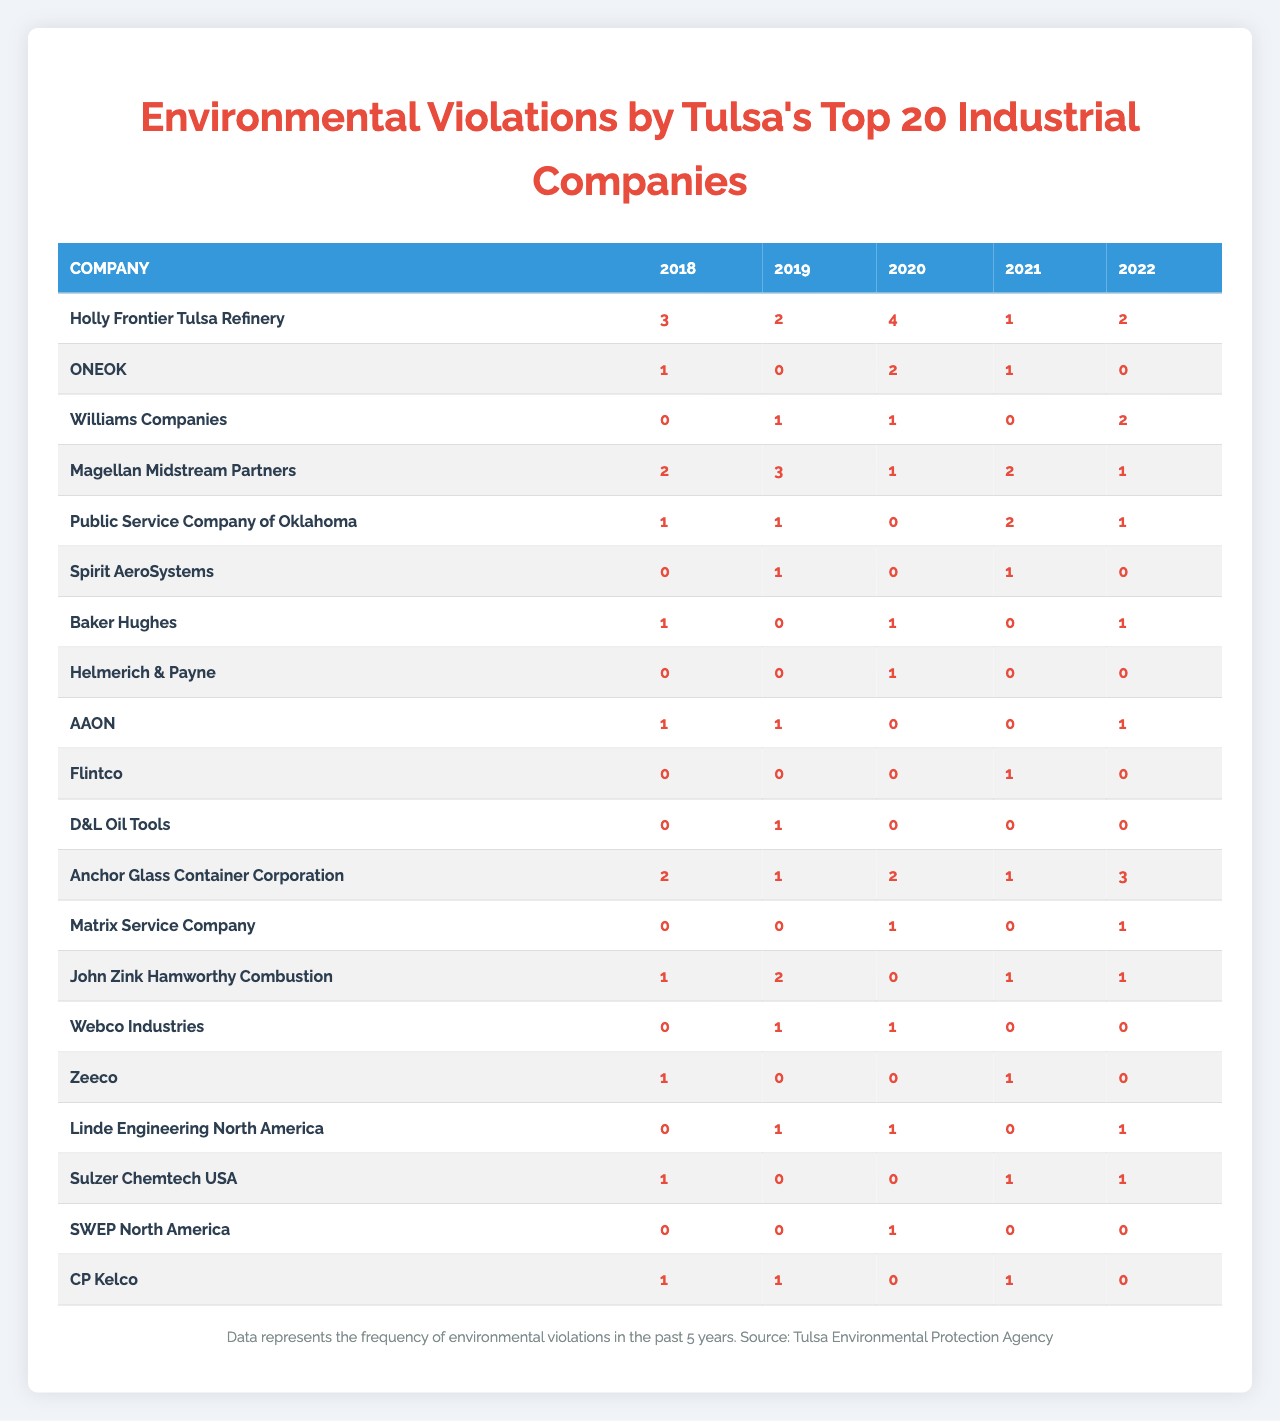What company had the highest total violations over the past 5 years? To find the company with the highest total violations, sum the violations for each company across all years. After calculating, Holly Frontier Tulsa Refinery has the highest total with 12 violations (3+2+4+1+2)
Answer: Holly Frontier Tulsa Refinery Which year had the most environmental violations overall? Sum the violations for each year: 2018 (12), 2019 (10), 2020 (11), 2021 (9), 2022 (12). Years 2018 and 2022 both have the highest total violations with 12 each.
Answer: 2018 and 2022 Did any company have zero violations in any year? Inspect the table to see if there are any years listed as zero for each company. AAON had zero violations in 2019, and ONEOK had zero violations in 2019 and 2022.
Answer: Yes What was the average number of violations for Williams Companies over the 5 years? Sum the violations for Williams Companies (0+1+1+0+2 = 4), then divide by the number of years (5): 4/5 = 0.8.
Answer: 0.8 Which company showed a decrease in violations from 2018 to 2022? Compare the violation counts for each company in 2018 (varies by company) and 2022 (2 for Holly Frontier, 0 for ONEOK, etc.). Only D&L Oil Tools had a decrease from 2 in 2018 to 0 in 2022.
Answer: D&L Oil Tools What is the total number of violations for all companies in 2020? Add all violations for 2020: 4+2+1+1+0+0+1+1+0+0+0+1+1+0+1+0+0+1+0+0 = 14.
Answer: 14 Which company consistently had the lowest violations each year? Review each row for consistency; Webco Industries only had 0 violations in 2020, and the total does not exceed 1 in any year.
Answer: Webco Industries Which company had the largest increase in violations from 2019 to 2020? Compare the violations from 2019 to 2020: Holly Frontier (2 to 4), D&L Oil Tools (1 to 2), Zeeco (0 to 1), etc. Holly Frontier Tulsa Refinery had the largest increase, going from 2 in 2019 to 4 in 2020 (increase of 2).
Answer: Holly Frontier Tulsa Refinery Is there a company that had the same number of violations for each year? Review the violation counts for any year showing identical counts. There is no company that shows identical counts each year; all counts vary.
Answer: No What is the median number of violations for Spirit AeroSystems over the 5 years? List the violations: 0, 1, 0, 1, 0; sorted list is 0, 0, 0, 1, 1, the median (middle value) is 0.
Answer: 0 